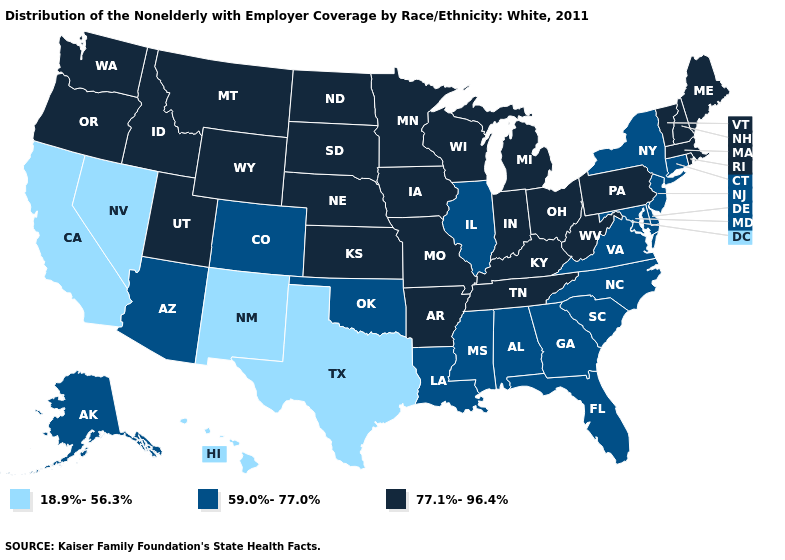Does Utah have a lower value than Kentucky?
Short answer required. No. Name the states that have a value in the range 59.0%-77.0%?
Concise answer only. Alabama, Alaska, Arizona, Colorado, Connecticut, Delaware, Florida, Georgia, Illinois, Louisiana, Maryland, Mississippi, New Jersey, New York, North Carolina, Oklahoma, South Carolina, Virginia. Does California have the lowest value in the USA?
Give a very brief answer. Yes. Is the legend a continuous bar?
Quick response, please. No. What is the value of North Dakota?
Be succinct. 77.1%-96.4%. What is the value of Idaho?
Short answer required. 77.1%-96.4%. Name the states that have a value in the range 18.9%-56.3%?
Quick response, please. California, Hawaii, Nevada, New Mexico, Texas. Name the states that have a value in the range 77.1%-96.4%?
Concise answer only. Arkansas, Idaho, Indiana, Iowa, Kansas, Kentucky, Maine, Massachusetts, Michigan, Minnesota, Missouri, Montana, Nebraska, New Hampshire, North Dakota, Ohio, Oregon, Pennsylvania, Rhode Island, South Dakota, Tennessee, Utah, Vermont, Washington, West Virginia, Wisconsin, Wyoming. What is the highest value in the USA?
Short answer required. 77.1%-96.4%. Among the states that border Washington , which have the lowest value?
Answer briefly. Idaho, Oregon. What is the value of Alabama?
Quick response, please. 59.0%-77.0%. Among the states that border Oklahoma , does New Mexico have the lowest value?
Short answer required. Yes. Which states have the highest value in the USA?
Answer briefly. Arkansas, Idaho, Indiana, Iowa, Kansas, Kentucky, Maine, Massachusetts, Michigan, Minnesota, Missouri, Montana, Nebraska, New Hampshire, North Dakota, Ohio, Oregon, Pennsylvania, Rhode Island, South Dakota, Tennessee, Utah, Vermont, Washington, West Virginia, Wisconsin, Wyoming. What is the value of Missouri?
Write a very short answer. 77.1%-96.4%. Name the states that have a value in the range 18.9%-56.3%?
Quick response, please. California, Hawaii, Nevada, New Mexico, Texas. 